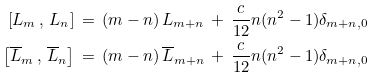Convert formula to latex. <formula><loc_0><loc_0><loc_500><loc_500>\left [ L _ { m } \, , \, L _ { n } \right ] \, = \, ( m - n ) \, L _ { m + n } \, + \, \frac { c } { 1 2 } n ( n ^ { 2 } - 1 ) \delta _ { m + n , 0 } \\ \left [ \overline { L } _ { m } \, , \, \overline { L } _ { n } \right ] \, = \, ( m - n ) \, \overline { L } _ { m + n } \, + \, \frac { c } { 1 2 } n ( n ^ { 2 } - 1 ) \delta _ { m + n , 0 }</formula> 